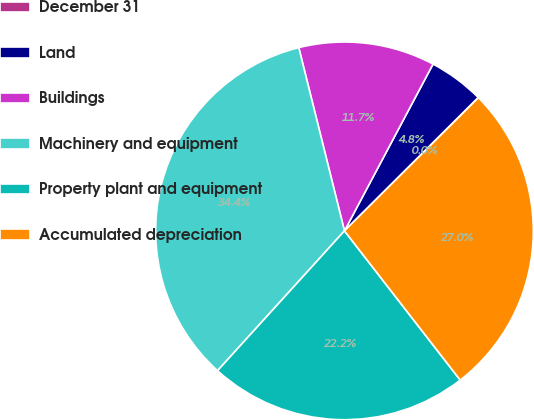Convert chart to OTSL. <chart><loc_0><loc_0><loc_500><loc_500><pie_chart><fcel>December 31<fcel>Land<fcel>Buildings<fcel>Machinery and equipment<fcel>Property plant and equipment<fcel>Accumulated depreciation<nl><fcel>0.03%<fcel>4.75%<fcel>11.66%<fcel>34.38%<fcel>22.23%<fcel>26.95%<nl></chart> 